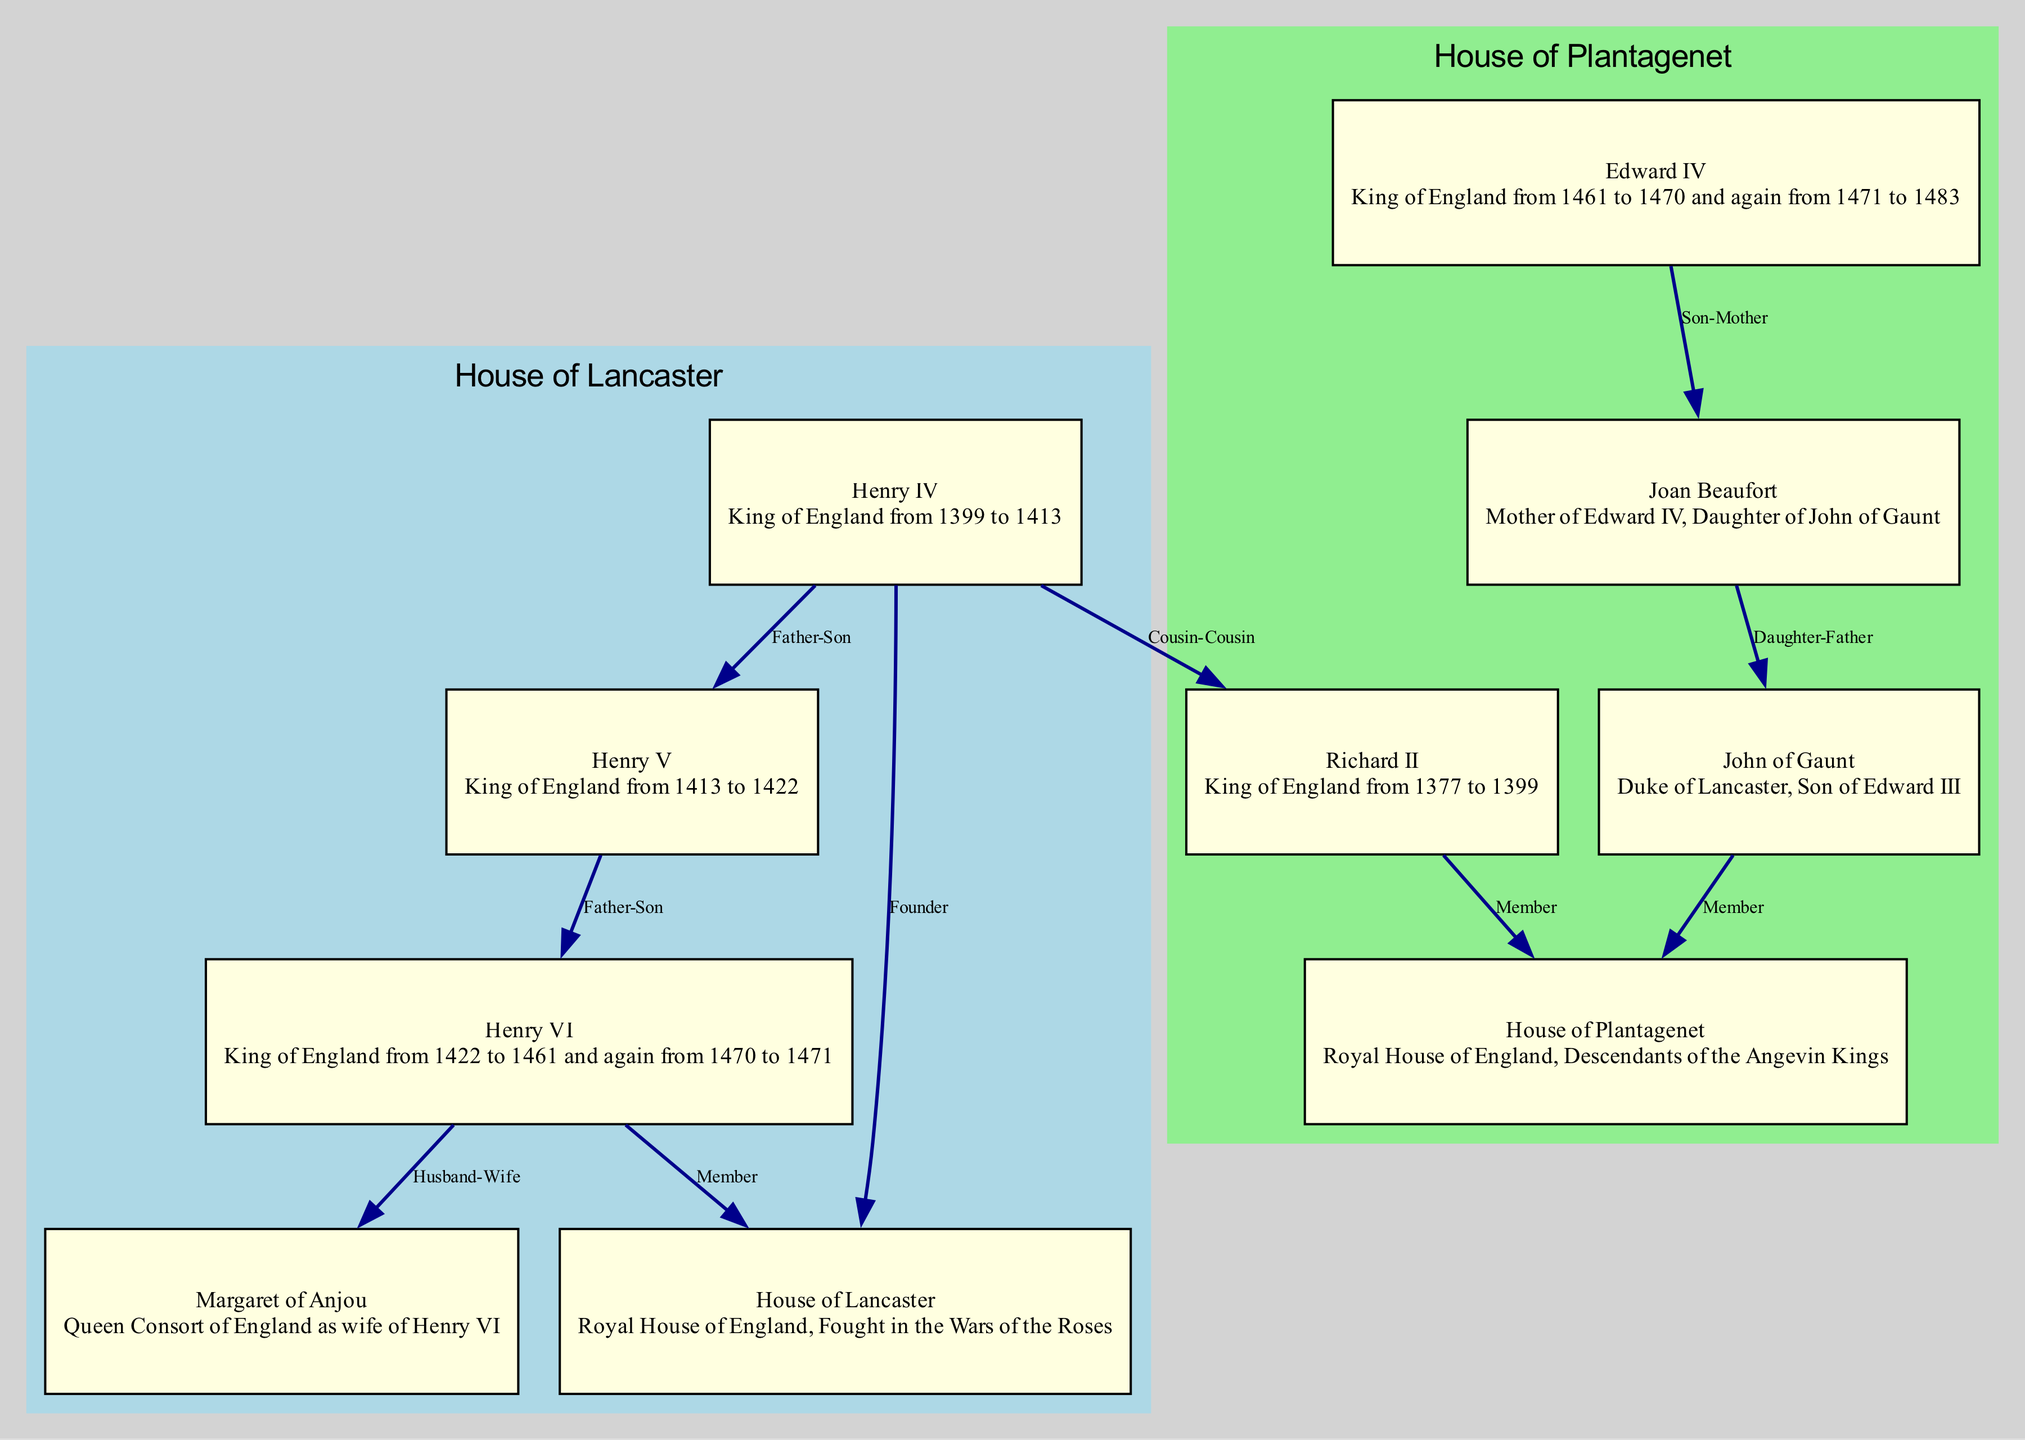What is the title of Henry V? The title of Henry V can be found in the node description in the diagram where it states "King of England from 1413 to 1422."
Answer: King of England from 1413 to 1422 How many nodes are in the diagram? The total number of nodes listed in the data is 10, which includes all the mentioned individuals and houses.
Answer: 10 Who is the father of Edward IV? By reviewing the edges in the diagram, we see that the edge from Edward IV to Joan Beaufort indicates a mother-son relationship, while Joan is noted as the daughter of John of Gaunt. Thus, Edward IV's father can be inferred as Henry VI because he is the next generational link in the House of Lancaster and leads down to Edward IV.
Answer: Henry VI Which two houses are represented in the diagram? The diagram includes both the House of Lancaster and the House of Plantagenet. This can be gathered from the nodes and subgraphs that categorize the families involved.
Answer: House of Lancaster, House of Plantagenet What relationship exists between Henry VI and Margaret of Anjou? The edge labeled "Husband-Wife" between Henry VI and Margaret of Anjou indicates that they are married. This relationship is visually depicted in the diagram's edges.
Answer: Husband-Wife Which member of the House of Plantagenet is also a member of the House of Lancaster? The diagram specifies through edges that Henry VI is a member of the House of Lancaster, and additionally, his lineage connects him to the House of Plantagenet through his parentage.
Answer: Henry VI Who is Joan Beaufort's father? The relationship shown in the diagram between Joan Beaufort and John of Gaunt indicates that John of Gaunt is her father, as specified in the daughter-father relationship edge.
Answer: John of Gaunt How many father-son relationships are depicted in the diagram? By examining the edges, there are three father-son relationships: Henry IV to Henry V, Henry V to Henry VI, and Edward IV to Joan Beaufort, with the last being maternal, thus only the first two count.
Answer: 2 Which king is indicated as the founder of the House of Lancaster? The diagram explicitly states that Henry IV has an edge labeled "Founder" to the House of Lancaster, identifying him as the founder.
Answer: Henry IV 